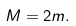<formula> <loc_0><loc_0><loc_500><loc_500>M = 2 m .</formula> 